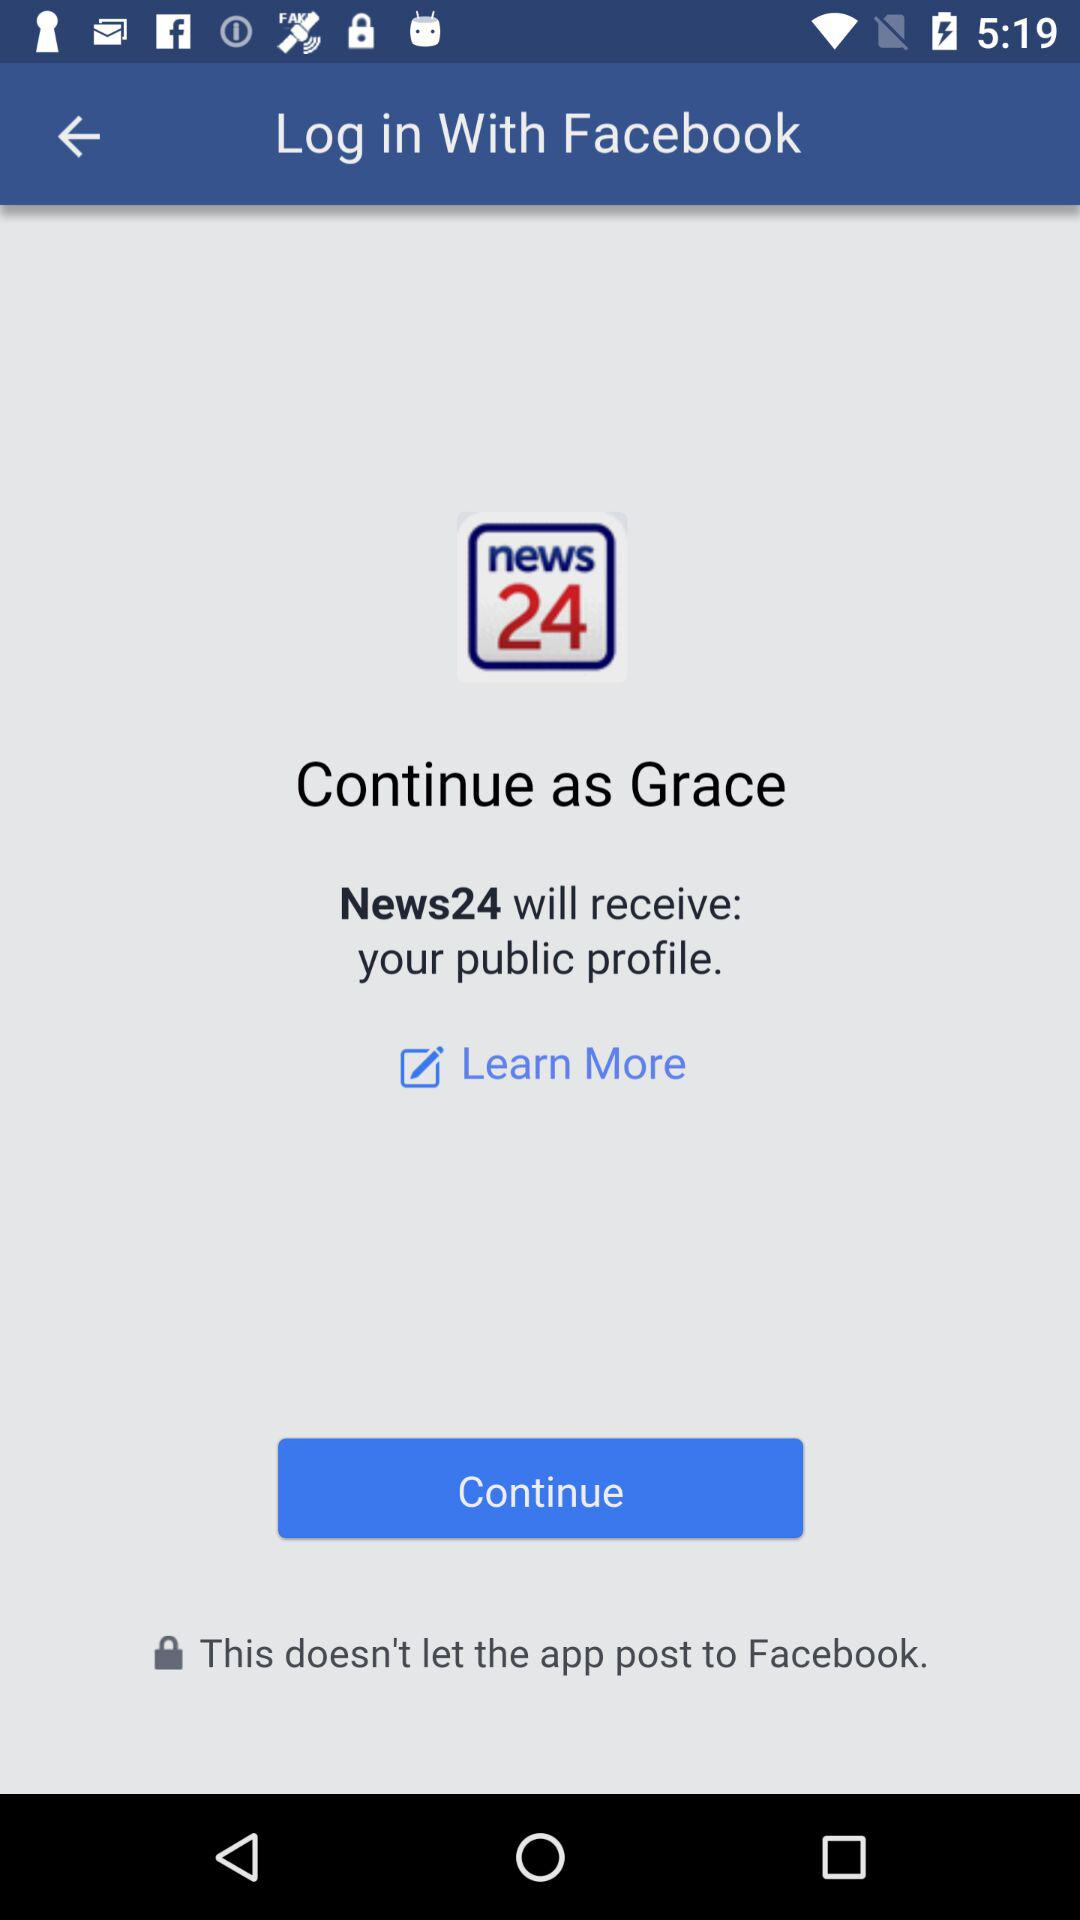What is the user name? The user name is Grace. 